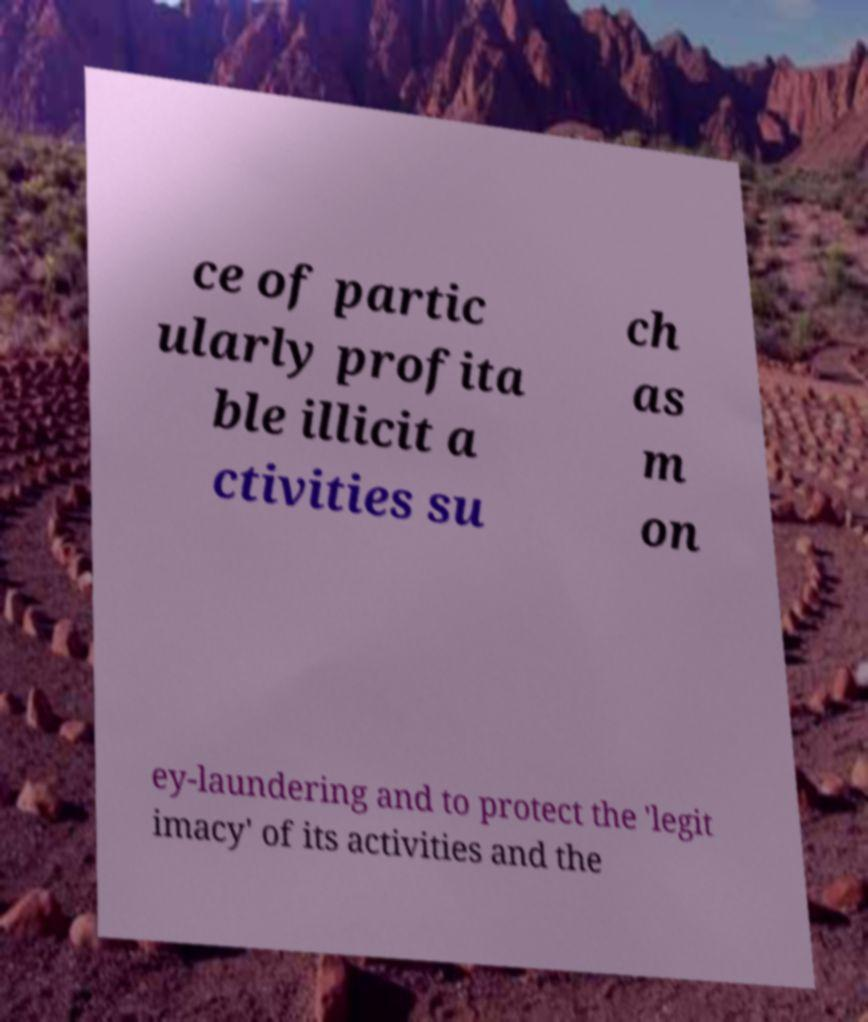I need the written content from this picture converted into text. Can you do that? ce of partic ularly profita ble illicit a ctivities su ch as m on ey-laundering and to protect the 'legit imacy' of its activities and the 